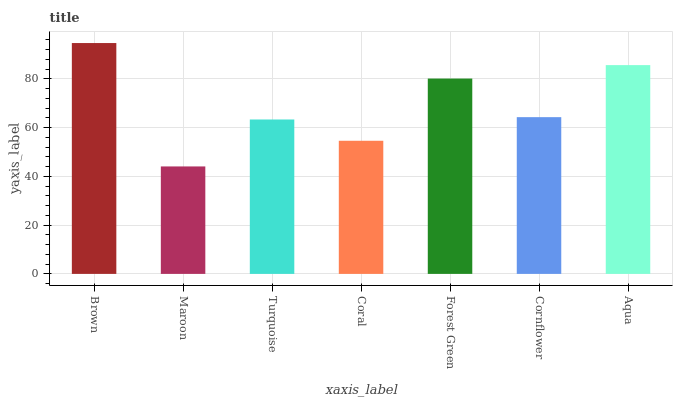Is Maroon the minimum?
Answer yes or no. Yes. Is Brown the maximum?
Answer yes or no. Yes. Is Turquoise the minimum?
Answer yes or no. No. Is Turquoise the maximum?
Answer yes or no. No. Is Turquoise greater than Maroon?
Answer yes or no. Yes. Is Maroon less than Turquoise?
Answer yes or no. Yes. Is Maroon greater than Turquoise?
Answer yes or no. No. Is Turquoise less than Maroon?
Answer yes or no. No. Is Cornflower the high median?
Answer yes or no. Yes. Is Cornflower the low median?
Answer yes or no. Yes. Is Forest Green the high median?
Answer yes or no. No. Is Aqua the low median?
Answer yes or no. No. 